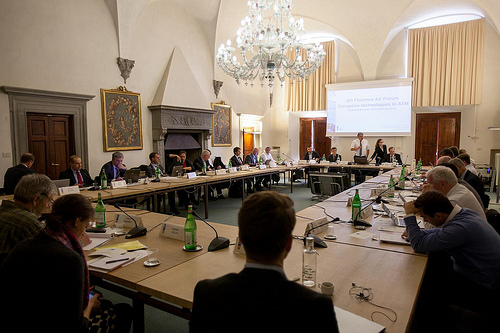<image>
Can you confirm if the mike is on the table? Yes. Looking at the image, I can see the mike is positioned on top of the table, with the table providing support. 